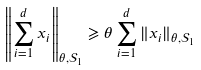Convert formula to latex. <formula><loc_0><loc_0><loc_500><loc_500>\left \| \sum _ { i = 1 } ^ { d } x _ { i } \right \| _ { \theta , \mathcal { S } _ { 1 } } \geqslant \theta \sum _ { i = 1 } ^ { d } \| x _ { i } \| _ { \theta , \mathcal { S } _ { 1 } }</formula> 